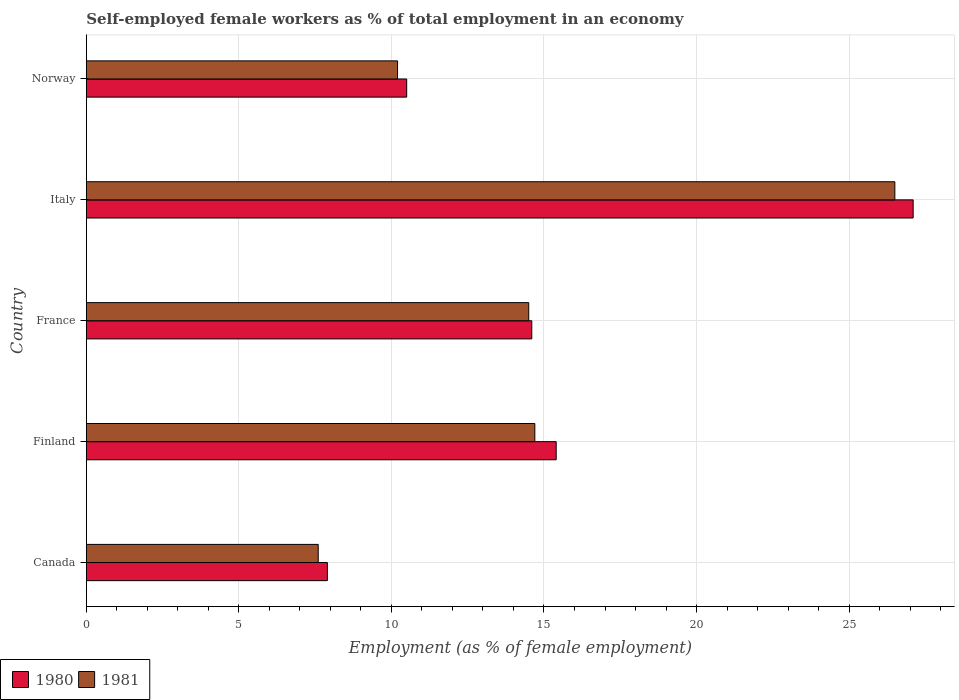How many groups of bars are there?
Ensure brevity in your answer.  5. Are the number of bars on each tick of the Y-axis equal?
Give a very brief answer. Yes. What is the label of the 5th group of bars from the top?
Ensure brevity in your answer.  Canada. What is the percentage of self-employed female workers in 1980 in Norway?
Keep it short and to the point. 10.5. Across all countries, what is the minimum percentage of self-employed female workers in 1981?
Ensure brevity in your answer.  7.6. In which country was the percentage of self-employed female workers in 1981 maximum?
Offer a terse response. Italy. In which country was the percentage of self-employed female workers in 1981 minimum?
Provide a short and direct response. Canada. What is the total percentage of self-employed female workers in 1980 in the graph?
Your answer should be compact. 75.5. What is the difference between the percentage of self-employed female workers in 1980 in Finland and that in France?
Provide a short and direct response. 0.8. What is the difference between the percentage of self-employed female workers in 1981 in Finland and the percentage of self-employed female workers in 1980 in Italy?
Offer a very short reply. -12.4. What is the average percentage of self-employed female workers in 1980 per country?
Give a very brief answer. 15.1. What is the difference between the percentage of self-employed female workers in 1981 and percentage of self-employed female workers in 1980 in Norway?
Make the answer very short. -0.3. In how many countries, is the percentage of self-employed female workers in 1981 greater than 6 %?
Make the answer very short. 5. What is the ratio of the percentage of self-employed female workers in 1981 in Canada to that in Norway?
Offer a very short reply. 0.75. Is the percentage of self-employed female workers in 1981 in Canada less than that in Norway?
Provide a short and direct response. Yes. What is the difference between the highest and the second highest percentage of self-employed female workers in 1980?
Offer a very short reply. 11.7. What is the difference between the highest and the lowest percentage of self-employed female workers in 1980?
Provide a succinct answer. 19.2. What does the 1st bar from the top in Italy represents?
Offer a very short reply. 1981. How many bars are there?
Offer a terse response. 10. Are all the bars in the graph horizontal?
Give a very brief answer. Yes. How many countries are there in the graph?
Make the answer very short. 5. What is the difference between two consecutive major ticks on the X-axis?
Ensure brevity in your answer.  5. Does the graph contain any zero values?
Make the answer very short. No. Does the graph contain grids?
Provide a succinct answer. Yes. Where does the legend appear in the graph?
Your answer should be very brief. Bottom left. How many legend labels are there?
Give a very brief answer. 2. What is the title of the graph?
Provide a short and direct response. Self-employed female workers as % of total employment in an economy. What is the label or title of the X-axis?
Make the answer very short. Employment (as % of female employment). What is the Employment (as % of female employment) of 1980 in Canada?
Provide a short and direct response. 7.9. What is the Employment (as % of female employment) in 1981 in Canada?
Make the answer very short. 7.6. What is the Employment (as % of female employment) of 1980 in Finland?
Your answer should be very brief. 15.4. What is the Employment (as % of female employment) in 1981 in Finland?
Make the answer very short. 14.7. What is the Employment (as % of female employment) in 1980 in France?
Keep it short and to the point. 14.6. What is the Employment (as % of female employment) in 1981 in France?
Provide a succinct answer. 14.5. What is the Employment (as % of female employment) in 1980 in Italy?
Provide a short and direct response. 27.1. What is the Employment (as % of female employment) in 1981 in Norway?
Keep it short and to the point. 10.2. Across all countries, what is the maximum Employment (as % of female employment) of 1980?
Offer a very short reply. 27.1. Across all countries, what is the minimum Employment (as % of female employment) in 1980?
Keep it short and to the point. 7.9. Across all countries, what is the minimum Employment (as % of female employment) of 1981?
Offer a very short reply. 7.6. What is the total Employment (as % of female employment) in 1980 in the graph?
Offer a very short reply. 75.5. What is the total Employment (as % of female employment) of 1981 in the graph?
Your answer should be compact. 73.5. What is the difference between the Employment (as % of female employment) in 1980 in Canada and that in Finland?
Make the answer very short. -7.5. What is the difference between the Employment (as % of female employment) in 1980 in Canada and that in France?
Keep it short and to the point. -6.7. What is the difference between the Employment (as % of female employment) in 1980 in Canada and that in Italy?
Keep it short and to the point. -19.2. What is the difference between the Employment (as % of female employment) of 1981 in Canada and that in Italy?
Ensure brevity in your answer.  -18.9. What is the difference between the Employment (as % of female employment) in 1981 in Canada and that in Norway?
Your response must be concise. -2.6. What is the difference between the Employment (as % of female employment) in 1980 in Finland and that in Norway?
Your answer should be very brief. 4.9. What is the difference between the Employment (as % of female employment) of 1981 in Finland and that in Norway?
Your response must be concise. 4.5. What is the difference between the Employment (as % of female employment) of 1980 in France and that in Italy?
Keep it short and to the point. -12.5. What is the difference between the Employment (as % of female employment) in 1981 in France and that in Norway?
Ensure brevity in your answer.  4.3. What is the difference between the Employment (as % of female employment) of 1981 in Italy and that in Norway?
Provide a short and direct response. 16.3. What is the difference between the Employment (as % of female employment) in 1980 in Canada and the Employment (as % of female employment) in 1981 in France?
Your answer should be compact. -6.6. What is the difference between the Employment (as % of female employment) of 1980 in Canada and the Employment (as % of female employment) of 1981 in Italy?
Your response must be concise. -18.6. What is the difference between the Employment (as % of female employment) in 1980 in Italy and the Employment (as % of female employment) in 1981 in Norway?
Provide a short and direct response. 16.9. What is the average Employment (as % of female employment) in 1980 per country?
Keep it short and to the point. 15.1. What is the difference between the Employment (as % of female employment) of 1980 and Employment (as % of female employment) of 1981 in France?
Give a very brief answer. 0.1. What is the difference between the Employment (as % of female employment) of 1980 and Employment (as % of female employment) of 1981 in Italy?
Keep it short and to the point. 0.6. What is the ratio of the Employment (as % of female employment) in 1980 in Canada to that in Finland?
Your answer should be very brief. 0.51. What is the ratio of the Employment (as % of female employment) of 1981 in Canada to that in Finland?
Provide a succinct answer. 0.52. What is the ratio of the Employment (as % of female employment) in 1980 in Canada to that in France?
Keep it short and to the point. 0.54. What is the ratio of the Employment (as % of female employment) of 1981 in Canada to that in France?
Offer a very short reply. 0.52. What is the ratio of the Employment (as % of female employment) of 1980 in Canada to that in Italy?
Make the answer very short. 0.29. What is the ratio of the Employment (as % of female employment) of 1981 in Canada to that in Italy?
Offer a very short reply. 0.29. What is the ratio of the Employment (as % of female employment) in 1980 in Canada to that in Norway?
Give a very brief answer. 0.75. What is the ratio of the Employment (as % of female employment) in 1981 in Canada to that in Norway?
Ensure brevity in your answer.  0.75. What is the ratio of the Employment (as % of female employment) of 1980 in Finland to that in France?
Give a very brief answer. 1.05. What is the ratio of the Employment (as % of female employment) in 1981 in Finland to that in France?
Your answer should be compact. 1.01. What is the ratio of the Employment (as % of female employment) in 1980 in Finland to that in Italy?
Your answer should be compact. 0.57. What is the ratio of the Employment (as % of female employment) of 1981 in Finland to that in Italy?
Your response must be concise. 0.55. What is the ratio of the Employment (as % of female employment) in 1980 in Finland to that in Norway?
Offer a very short reply. 1.47. What is the ratio of the Employment (as % of female employment) of 1981 in Finland to that in Norway?
Provide a short and direct response. 1.44. What is the ratio of the Employment (as % of female employment) of 1980 in France to that in Italy?
Ensure brevity in your answer.  0.54. What is the ratio of the Employment (as % of female employment) in 1981 in France to that in Italy?
Offer a terse response. 0.55. What is the ratio of the Employment (as % of female employment) of 1980 in France to that in Norway?
Offer a terse response. 1.39. What is the ratio of the Employment (as % of female employment) of 1981 in France to that in Norway?
Your answer should be compact. 1.42. What is the ratio of the Employment (as % of female employment) of 1980 in Italy to that in Norway?
Offer a terse response. 2.58. What is the ratio of the Employment (as % of female employment) of 1981 in Italy to that in Norway?
Give a very brief answer. 2.6. What is the difference between the highest and the lowest Employment (as % of female employment) in 1981?
Your response must be concise. 18.9. 